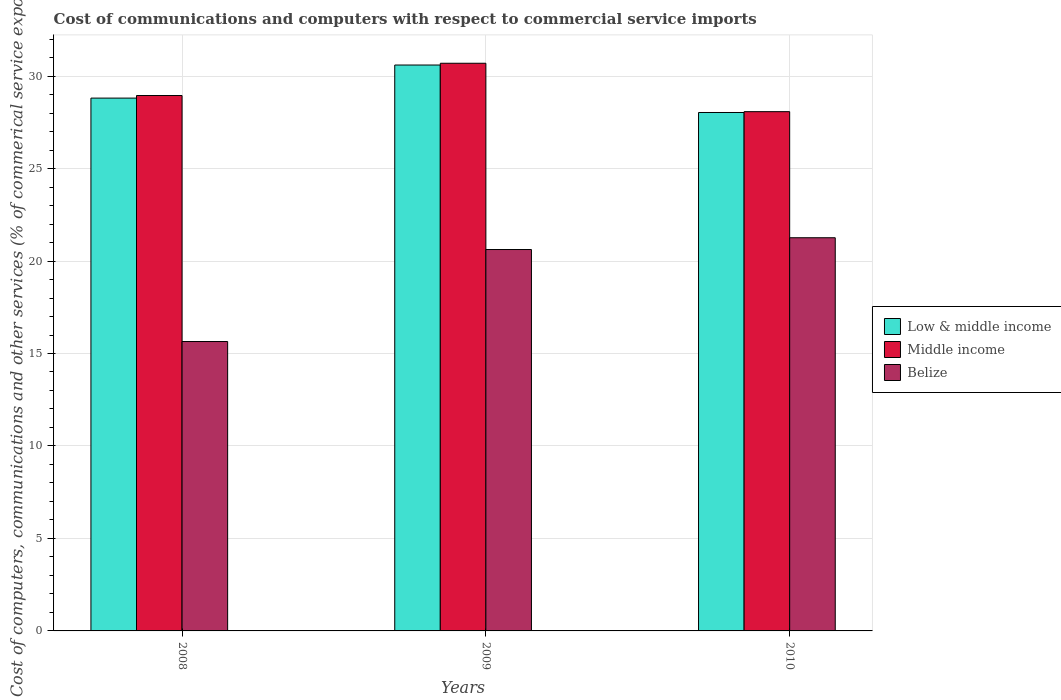How many different coloured bars are there?
Give a very brief answer. 3. How many groups of bars are there?
Offer a terse response. 3. Are the number of bars on each tick of the X-axis equal?
Ensure brevity in your answer.  Yes. How many bars are there on the 1st tick from the left?
Make the answer very short. 3. What is the label of the 2nd group of bars from the left?
Your response must be concise. 2009. What is the cost of communications and computers in Belize in 2010?
Your answer should be compact. 21.26. Across all years, what is the maximum cost of communications and computers in Low & middle income?
Provide a short and direct response. 30.6. Across all years, what is the minimum cost of communications and computers in Low & middle income?
Ensure brevity in your answer.  28.03. What is the total cost of communications and computers in Middle income in the graph?
Give a very brief answer. 87.72. What is the difference between the cost of communications and computers in Middle income in 2009 and that in 2010?
Give a very brief answer. 2.62. What is the difference between the cost of communications and computers in Middle income in 2008 and the cost of communications and computers in Low & middle income in 2010?
Offer a terse response. 0.92. What is the average cost of communications and computers in Low & middle income per year?
Your answer should be very brief. 29.15. In the year 2008, what is the difference between the cost of communications and computers in Belize and cost of communications and computers in Low & middle income?
Your answer should be compact. -13.16. In how many years, is the cost of communications and computers in Belize greater than 10 %?
Offer a terse response. 3. What is the ratio of the cost of communications and computers in Belize in 2008 to that in 2009?
Provide a succinct answer. 0.76. Is the difference between the cost of communications and computers in Belize in 2009 and 2010 greater than the difference between the cost of communications and computers in Low & middle income in 2009 and 2010?
Give a very brief answer. No. What is the difference between the highest and the second highest cost of communications and computers in Middle income?
Your answer should be compact. 1.74. What is the difference between the highest and the lowest cost of communications and computers in Low & middle income?
Your answer should be compact. 2.57. In how many years, is the cost of communications and computers in Belize greater than the average cost of communications and computers in Belize taken over all years?
Keep it short and to the point. 2. Is the sum of the cost of communications and computers in Belize in 2008 and 2009 greater than the maximum cost of communications and computers in Middle income across all years?
Ensure brevity in your answer.  Yes. Is it the case that in every year, the sum of the cost of communications and computers in Belize and cost of communications and computers in Low & middle income is greater than the cost of communications and computers in Middle income?
Offer a terse response. Yes. How many bars are there?
Your response must be concise. 9. Are all the bars in the graph horizontal?
Keep it short and to the point. No. How many years are there in the graph?
Provide a short and direct response. 3. What is the difference between two consecutive major ticks on the Y-axis?
Provide a succinct answer. 5. Are the values on the major ticks of Y-axis written in scientific E-notation?
Your answer should be very brief. No. Does the graph contain any zero values?
Give a very brief answer. No. Where does the legend appear in the graph?
Your response must be concise. Center right. How many legend labels are there?
Your response must be concise. 3. What is the title of the graph?
Your answer should be very brief. Cost of communications and computers with respect to commercial service imports. What is the label or title of the X-axis?
Provide a short and direct response. Years. What is the label or title of the Y-axis?
Provide a short and direct response. Cost of computers, communications and other services (% of commerical service exports). What is the Cost of computers, communications and other services (% of commerical service exports) of Low & middle income in 2008?
Your response must be concise. 28.81. What is the Cost of computers, communications and other services (% of commerical service exports) of Middle income in 2008?
Your response must be concise. 28.95. What is the Cost of computers, communications and other services (% of commerical service exports) in Belize in 2008?
Provide a succinct answer. 15.65. What is the Cost of computers, communications and other services (% of commerical service exports) of Low & middle income in 2009?
Offer a terse response. 30.6. What is the Cost of computers, communications and other services (% of commerical service exports) in Middle income in 2009?
Ensure brevity in your answer.  30.69. What is the Cost of computers, communications and other services (% of commerical service exports) in Belize in 2009?
Keep it short and to the point. 20.62. What is the Cost of computers, communications and other services (% of commerical service exports) in Low & middle income in 2010?
Keep it short and to the point. 28.03. What is the Cost of computers, communications and other services (% of commerical service exports) in Middle income in 2010?
Offer a very short reply. 28.08. What is the Cost of computers, communications and other services (% of commerical service exports) in Belize in 2010?
Provide a short and direct response. 21.26. Across all years, what is the maximum Cost of computers, communications and other services (% of commerical service exports) in Low & middle income?
Make the answer very short. 30.6. Across all years, what is the maximum Cost of computers, communications and other services (% of commerical service exports) of Middle income?
Provide a short and direct response. 30.69. Across all years, what is the maximum Cost of computers, communications and other services (% of commerical service exports) of Belize?
Your response must be concise. 21.26. Across all years, what is the minimum Cost of computers, communications and other services (% of commerical service exports) of Low & middle income?
Make the answer very short. 28.03. Across all years, what is the minimum Cost of computers, communications and other services (% of commerical service exports) of Middle income?
Make the answer very short. 28.08. Across all years, what is the minimum Cost of computers, communications and other services (% of commerical service exports) in Belize?
Offer a terse response. 15.65. What is the total Cost of computers, communications and other services (% of commerical service exports) in Low & middle income in the graph?
Make the answer very short. 87.44. What is the total Cost of computers, communications and other services (% of commerical service exports) in Middle income in the graph?
Provide a succinct answer. 87.72. What is the total Cost of computers, communications and other services (% of commerical service exports) in Belize in the graph?
Ensure brevity in your answer.  57.53. What is the difference between the Cost of computers, communications and other services (% of commerical service exports) in Low & middle income in 2008 and that in 2009?
Offer a very short reply. -1.79. What is the difference between the Cost of computers, communications and other services (% of commerical service exports) in Middle income in 2008 and that in 2009?
Your response must be concise. -1.74. What is the difference between the Cost of computers, communications and other services (% of commerical service exports) in Belize in 2008 and that in 2009?
Offer a very short reply. -4.97. What is the difference between the Cost of computers, communications and other services (% of commerical service exports) of Low & middle income in 2008 and that in 2010?
Offer a terse response. 0.78. What is the difference between the Cost of computers, communications and other services (% of commerical service exports) in Middle income in 2008 and that in 2010?
Offer a very short reply. 0.87. What is the difference between the Cost of computers, communications and other services (% of commerical service exports) in Belize in 2008 and that in 2010?
Provide a succinct answer. -5.61. What is the difference between the Cost of computers, communications and other services (% of commerical service exports) in Low & middle income in 2009 and that in 2010?
Offer a terse response. 2.57. What is the difference between the Cost of computers, communications and other services (% of commerical service exports) of Middle income in 2009 and that in 2010?
Give a very brief answer. 2.62. What is the difference between the Cost of computers, communications and other services (% of commerical service exports) of Belize in 2009 and that in 2010?
Ensure brevity in your answer.  -0.64. What is the difference between the Cost of computers, communications and other services (% of commerical service exports) of Low & middle income in 2008 and the Cost of computers, communications and other services (% of commerical service exports) of Middle income in 2009?
Offer a very short reply. -1.88. What is the difference between the Cost of computers, communications and other services (% of commerical service exports) in Low & middle income in 2008 and the Cost of computers, communications and other services (% of commerical service exports) in Belize in 2009?
Give a very brief answer. 8.19. What is the difference between the Cost of computers, communications and other services (% of commerical service exports) of Middle income in 2008 and the Cost of computers, communications and other services (% of commerical service exports) of Belize in 2009?
Make the answer very short. 8.33. What is the difference between the Cost of computers, communications and other services (% of commerical service exports) in Low & middle income in 2008 and the Cost of computers, communications and other services (% of commerical service exports) in Middle income in 2010?
Your answer should be compact. 0.73. What is the difference between the Cost of computers, communications and other services (% of commerical service exports) in Low & middle income in 2008 and the Cost of computers, communications and other services (% of commerical service exports) in Belize in 2010?
Give a very brief answer. 7.55. What is the difference between the Cost of computers, communications and other services (% of commerical service exports) in Middle income in 2008 and the Cost of computers, communications and other services (% of commerical service exports) in Belize in 2010?
Give a very brief answer. 7.69. What is the difference between the Cost of computers, communications and other services (% of commerical service exports) in Low & middle income in 2009 and the Cost of computers, communications and other services (% of commerical service exports) in Middle income in 2010?
Make the answer very short. 2.52. What is the difference between the Cost of computers, communications and other services (% of commerical service exports) of Low & middle income in 2009 and the Cost of computers, communications and other services (% of commerical service exports) of Belize in 2010?
Your answer should be very brief. 9.34. What is the difference between the Cost of computers, communications and other services (% of commerical service exports) in Middle income in 2009 and the Cost of computers, communications and other services (% of commerical service exports) in Belize in 2010?
Provide a short and direct response. 9.43. What is the average Cost of computers, communications and other services (% of commerical service exports) of Low & middle income per year?
Your answer should be very brief. 29.15. What is the average Cost of computers, communications and other services (% of commerical service exports) of Middle income per year?
Give a very brief answer. 29.24. What is the average Cost of computers, communications and other services (% of commerical service exports) of Belize per year?
Your response must be concise. 19.18. In the year 2008, what is the difference between the Cost of computers, communications and other services (% of commerical service exports) of Low & middle income and Cost of computers, communications and other services (% of commerical service exports) of Middle income?
Offer a terse response. -0.14. In the year 2008, what is the difference between the Cost of computers, communications and other services (% of commerical service exports) in Low & middle income and Cost of computers, communications and other services (% of commerical service exports) in Belize?
Ensure brevity in your answer.  13.16. In the year 2008, what is the difference between the Cost of computers, communications and other services (% of commerical service exports) of Middle income and Cost of computers, communications and other services (% of commerical service exports) of Belize?
Make the answer very short. 13.3. In the year 2009, what is the difference between the Cost of computers, communications and other services (% of commerical service exports) in Low & middle income and Cost of computers, communications and other services (% of commerical service exports) in Middle income?
Ensure brevity in your answer.  -0.1. In the year 2009, what is the difference between the Cost of computers, communications and other services (% of commerical service exports) in Low & middle income and Cost of computers, communications and other services (% of commerical service exports) in Belize?
Keep it short and to the point. 9.98. In the year 2009, what is the difference between the Cost of computers, communications and other services (% of commerical service exports) in Middle income and Cost of computers, communications and other services (% of commerical service exports) in Belize?
Ensure brevity in your answer.  10.07. In the year 2010, what is the difference between the Cost of computers, communications and other services (% of commerical service exports) of Low & middle income and Cost of computers, communications and other services (% of commerical service exports) of Middle income?
Your answer should be compact. -0.05. In the year 2010, what is the difference between the Cost of computers, communications and other services (% of commerical service exports) in Low & middle income and Cost of computers, communications and other services (% of commerical service exports) in Belize?
Your answer should be very brief. 6.77. In the year 2010, what is the difference between the Cost of computers, communications and other services (% of commerical service exports) in Middle income and Cost of computers, communications and other services (% of commerical service exports) in Belize?
Keep it short and to the point. 6.82. What is the ratio of the Cost of computers, communications and other services (% of commerical service exports) of Low & middle income in 2008 to that in 2009?
Offer a terse response. 0.94. What is the ratio of the Cost of computers, communications and other services (% of commerical service exports) of Middle income in 2008 to that in 2009?
Ensure brevity in your answer.  0.94. What is the ratio of the Cost of computers, communications and other services (% of commerical service exports) in Belize in 2008 to that in 2009?
Your answer should be very brief. 0.76. What is the ratio of the Cost of computers, communications and other services (% of commerical service exports) of Low & middle income in 2008 to that in 2010?
Offer a very short reply. 1.03. What is the ratio of the Cost of computers, communications and other services (% of commerical service exports) in Middle income in 2008 to that in 2010?
Make the answer very short. 1.03. What is the ratio of the Cost of computers, communications and other services (% of commerical service exports) of Belize in 2008 to that in 2010?
Offer a terse response. 0.74. What is the ratio of the Cost of computers, communications and other services (% of commerical service exports) in Low & middle income in 2009 to that in 2010?
Give a very brief answer. 1.09. What is the ratio of the Cost of computers, communications and other services (% of commerical service exports) of Middle income in 2009 to that in 2010?
Make the answer very short. 1.09. What is the ratio of the Cost of computers, communications and other services (% of commerical service exports) in Belize in 2009 to that in 2010?
Your answer should be very brief. 0.97. What is the difference between the highest and the second highest Cost of computers, communications and other services (% of commerical service exports) of Low & middle income?
Provide a short and direct response. 1.79. What is the difference between the highest and the second highest Cost of computers, communications and other services (% of commerical service exports) in Middle income?
Give a very brief answer. 1.74. What is the difference between the highest and the second highest Cost of computers, communications and other services (% of commerical service exports) in Belize?
Keep it short and to the point. 0.64. What is the difference between the highest and the lowest Cost of computers, communications and other services (% of commerical service exports) in Low & middle income?
Make the answer very short. 2.57. What is the difference between the highest and the lowest Cost of computers, communications and other services (% of commerical service exports) in Middle income?
Keep it short and to the point. 2.62. What is the difference between the highest and the lowest Cost of computers, communications and other services (% of commerical service exports) in Belize?
Your answer should be compact. 5.61. 